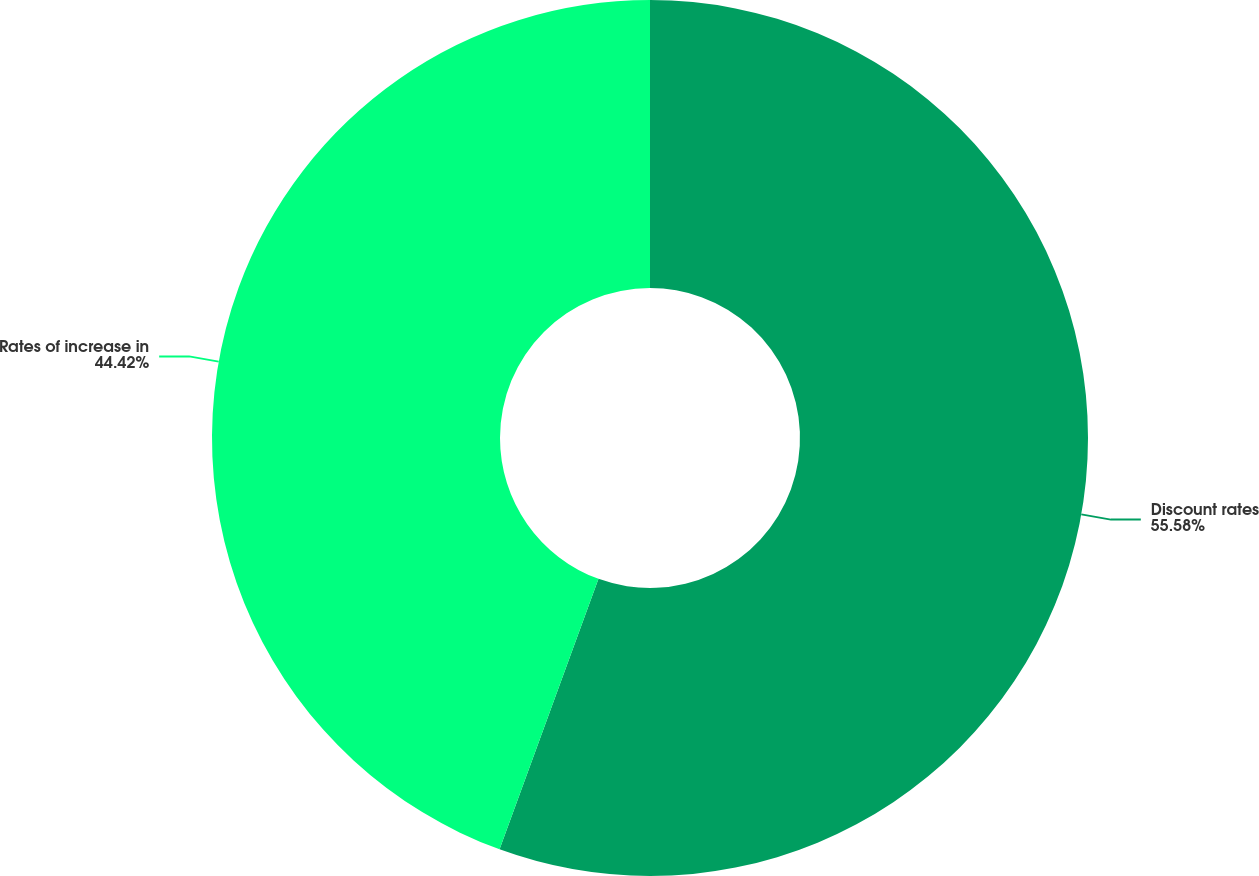Convert chart to OTSL. <chart><loc_0><loc_0><loc_500><loc_500><pie_chart><fcel>Discount rates<fcel>Rates of increase in<nl><fcel>55.58%<fcel>44.42%<nl></chart> 